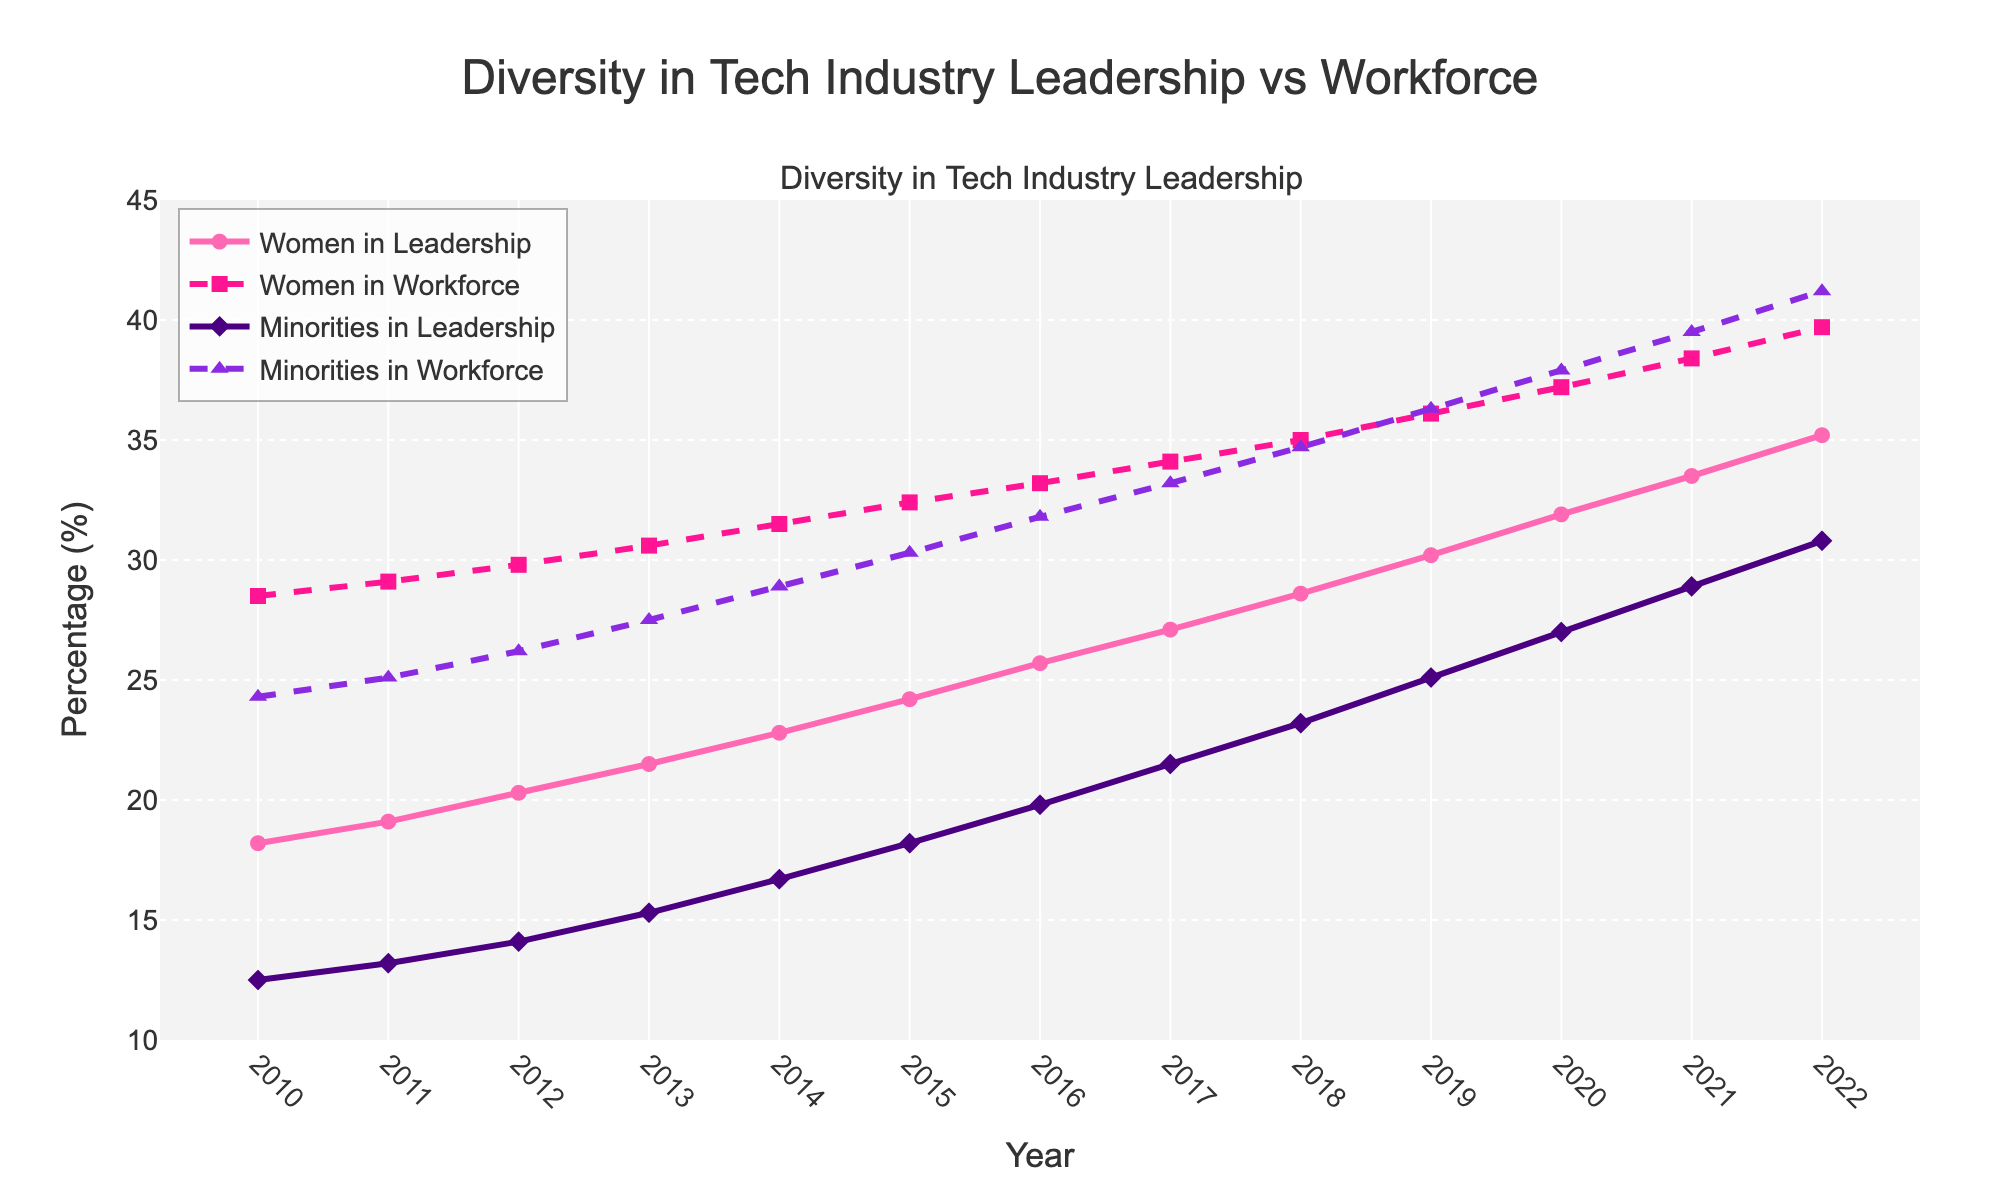What is the percentage increase in the representation of women in leadership from 2010 to 2022? The percentage of women in leadership in 2010 is 18.2%, and in 2022 it is 35.2%. Subtract the 2010 value from the 2022 value to get the increase: 35.2 - 18.2 = 17%.
Answer: 17% How does the percentage of minorities in leadership in 2015 compare to the percentage of minorities in the workforce in the same year? In 2015, the percentage of minorities in leadership is 18.2%, and in the workforce, it is 30.3%. Comparing these, 18.2% is smaller than 30.3%.
Answer: Minorities in leadership are less represented than in the workforce Which year shows the smallest gap between the percentage of women in leadership and women in the workforce? Calculate the gaps for each year: (2022: 4.5%, 2021: 4.9%, 2020: 5.3%, and so on). The year with the smallest gap is 2022 (39.7% - 35.2% = 4.5%).
Answer: 2022 What is the average percentage of minorities in leadership from 2010 to 2022? Add the percentages from each year and then divide by the number of years. Sum = (12.5 + 13.2 + 14.1 + 15.3 + 16.7 + 18.2 + 19.8 + 21.5 + 23.2 + 25.1 + 27.0 + 28.9 + 30.8) = 276.3. Divide by 13 years: 276.3 / 13 ≈ 21.25%.
Answer: 21.25% Which group had the highest increase in representation from 2010 to 2022, women in leadership or minorities in leadership? Calculate the percentage increase for each group: Women in leadership increased from 18.2% to 35.2%, which is an increase of 17%. Minorities in leadership increased from 12.5% to 30.8%, which is an increase of 18.3%.
Answer: Minorities in leadership In which year do women in the workforce cross the 30% mark? Looking at the figure, the percentage of women in the workforce crosses the 30% mark in 2013 (30.6%).
Answer: 2013 Compare the trends of representation in leadership for both women and minorities from 2010 to 2022. What do you notice? Both lines show a positive trend, meaning increases over time. The rate of increase for minorities in leadership appears slightly greater than for women in leadership, particularly from 2018 onwards.
Answer: Both increased, but minorities had a slightly sharper rise after 2018 In what year does the percentage of minorities in the workforce exceed 40%? Observing the plot, minorities in the workforce exceed the 40% mark in 2022 (41.2%).
Answer: 2022 